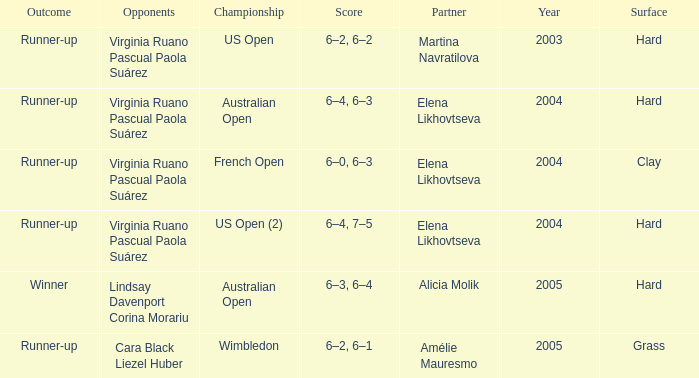When winner is the outcome what is the score? 6–3, 6–4. 